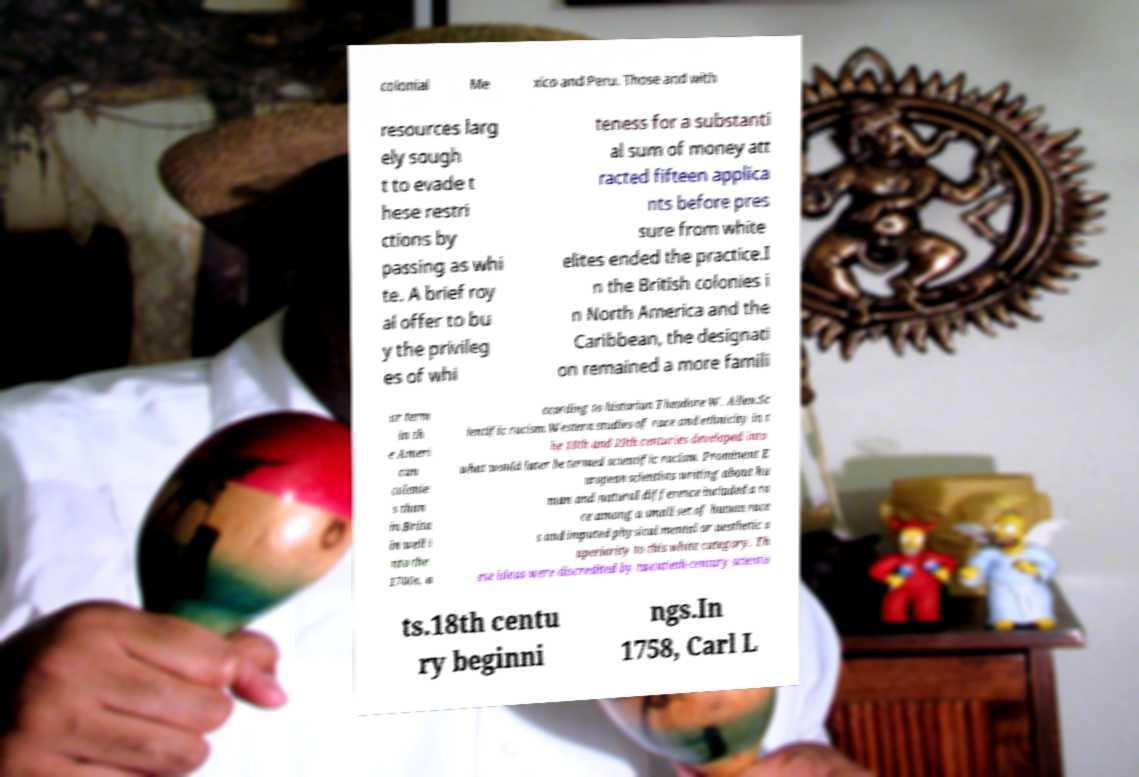What messages or text are displayed in this image? I need them in a readable, typed format. colonial Me xico and Peru. Those and with resources larg ely sough t to evade t hese restri ctions by passing as whi te. A brief roy al offer to bu y the privileg es of whi teness for a substanti al sum of money att racted fifteen applica nts before pres sure from white elites ended the practice.I n the British colonies i n North America and the Caribbean, the designati on remained a more famili ar term in th e Ameri can colonie s than in Brita in well i nto the 1700s, a ccording to historian Theodore W. Allen.Sc ientific racism.Western studies of race and ethnicity in t he 18th and 19th centuries developed into what would later be termed scientific racism. Prominent E uropean scientists writing about hu man and natural difference included a ra ce among a small set of human race s and imputed physical mental or aesthetic s uperiority to this white category. Th ese ideas were discredited by twentieth-century scientis ts.18th centu ry beginni ngs.In 1758, Carl L 